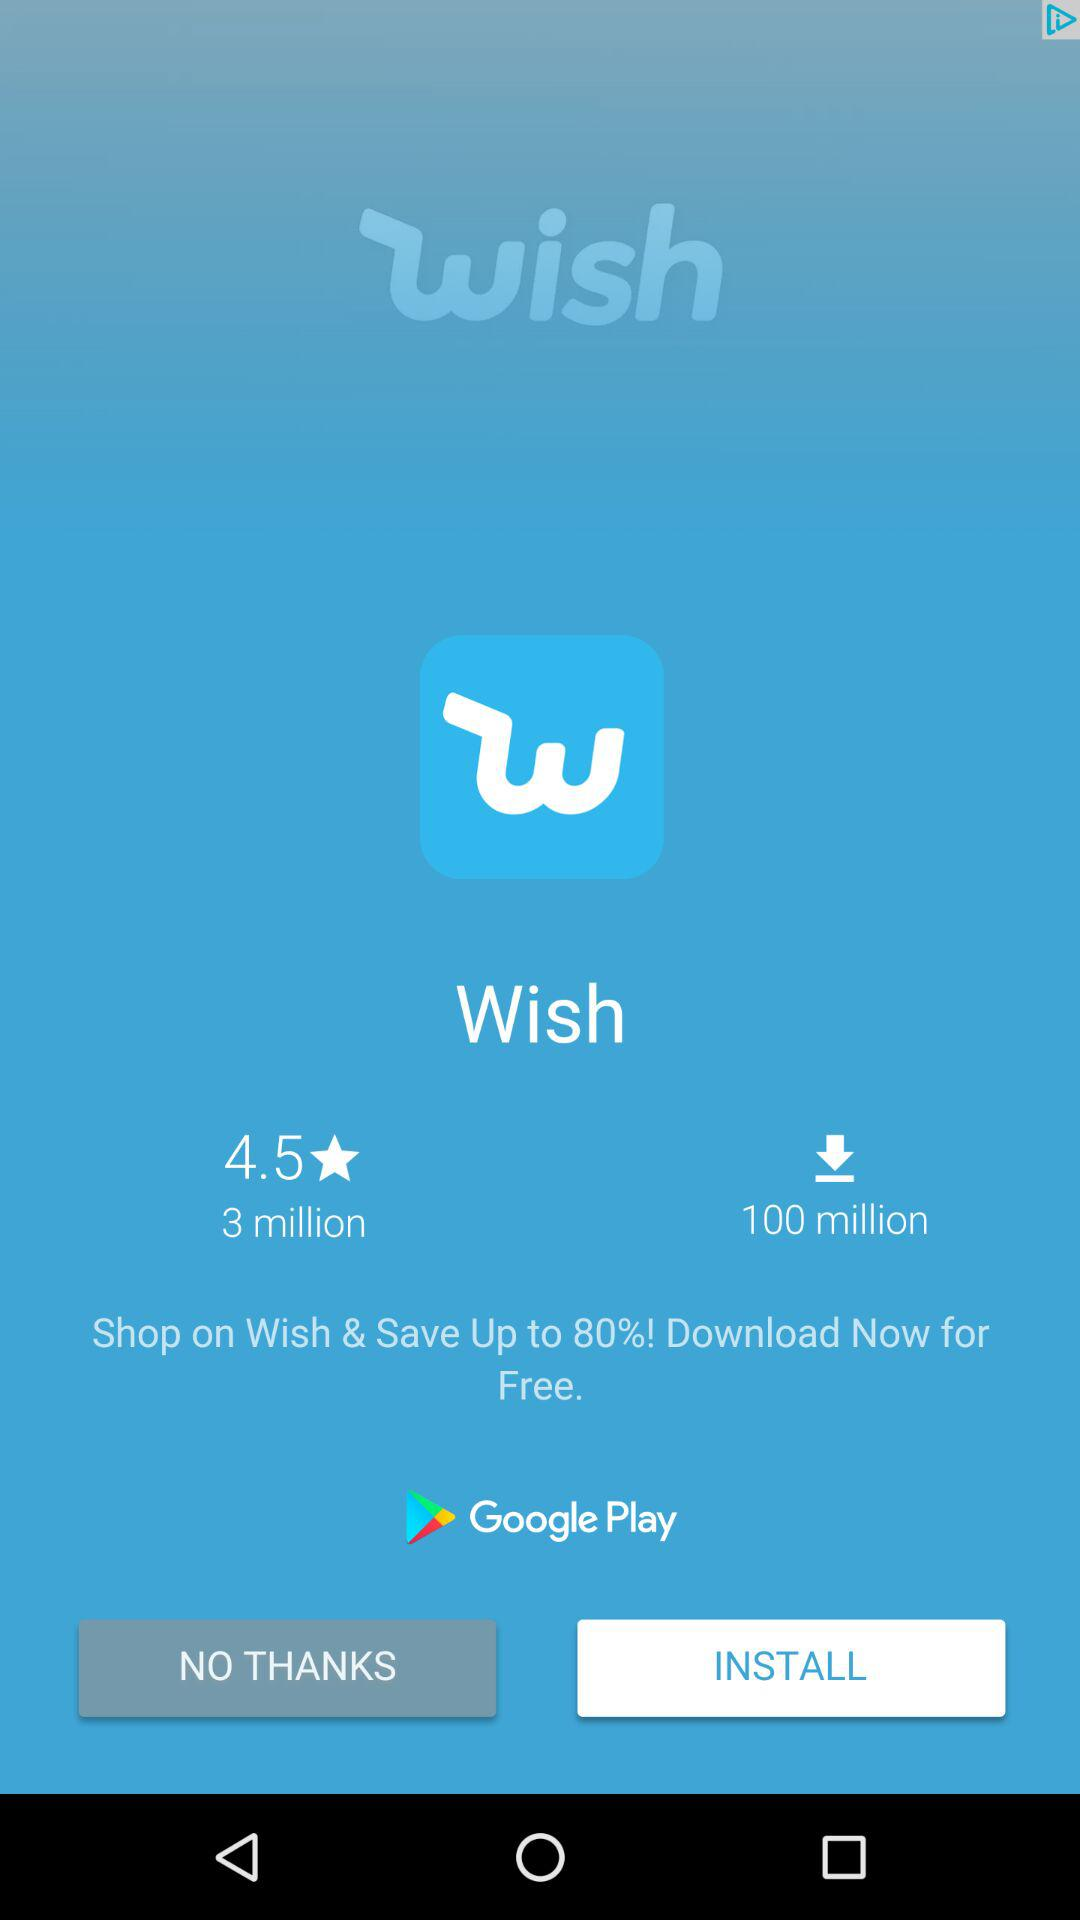How many more downloads does Wish have than reviews?
Answer the question using a single word or phrase. 97 million 